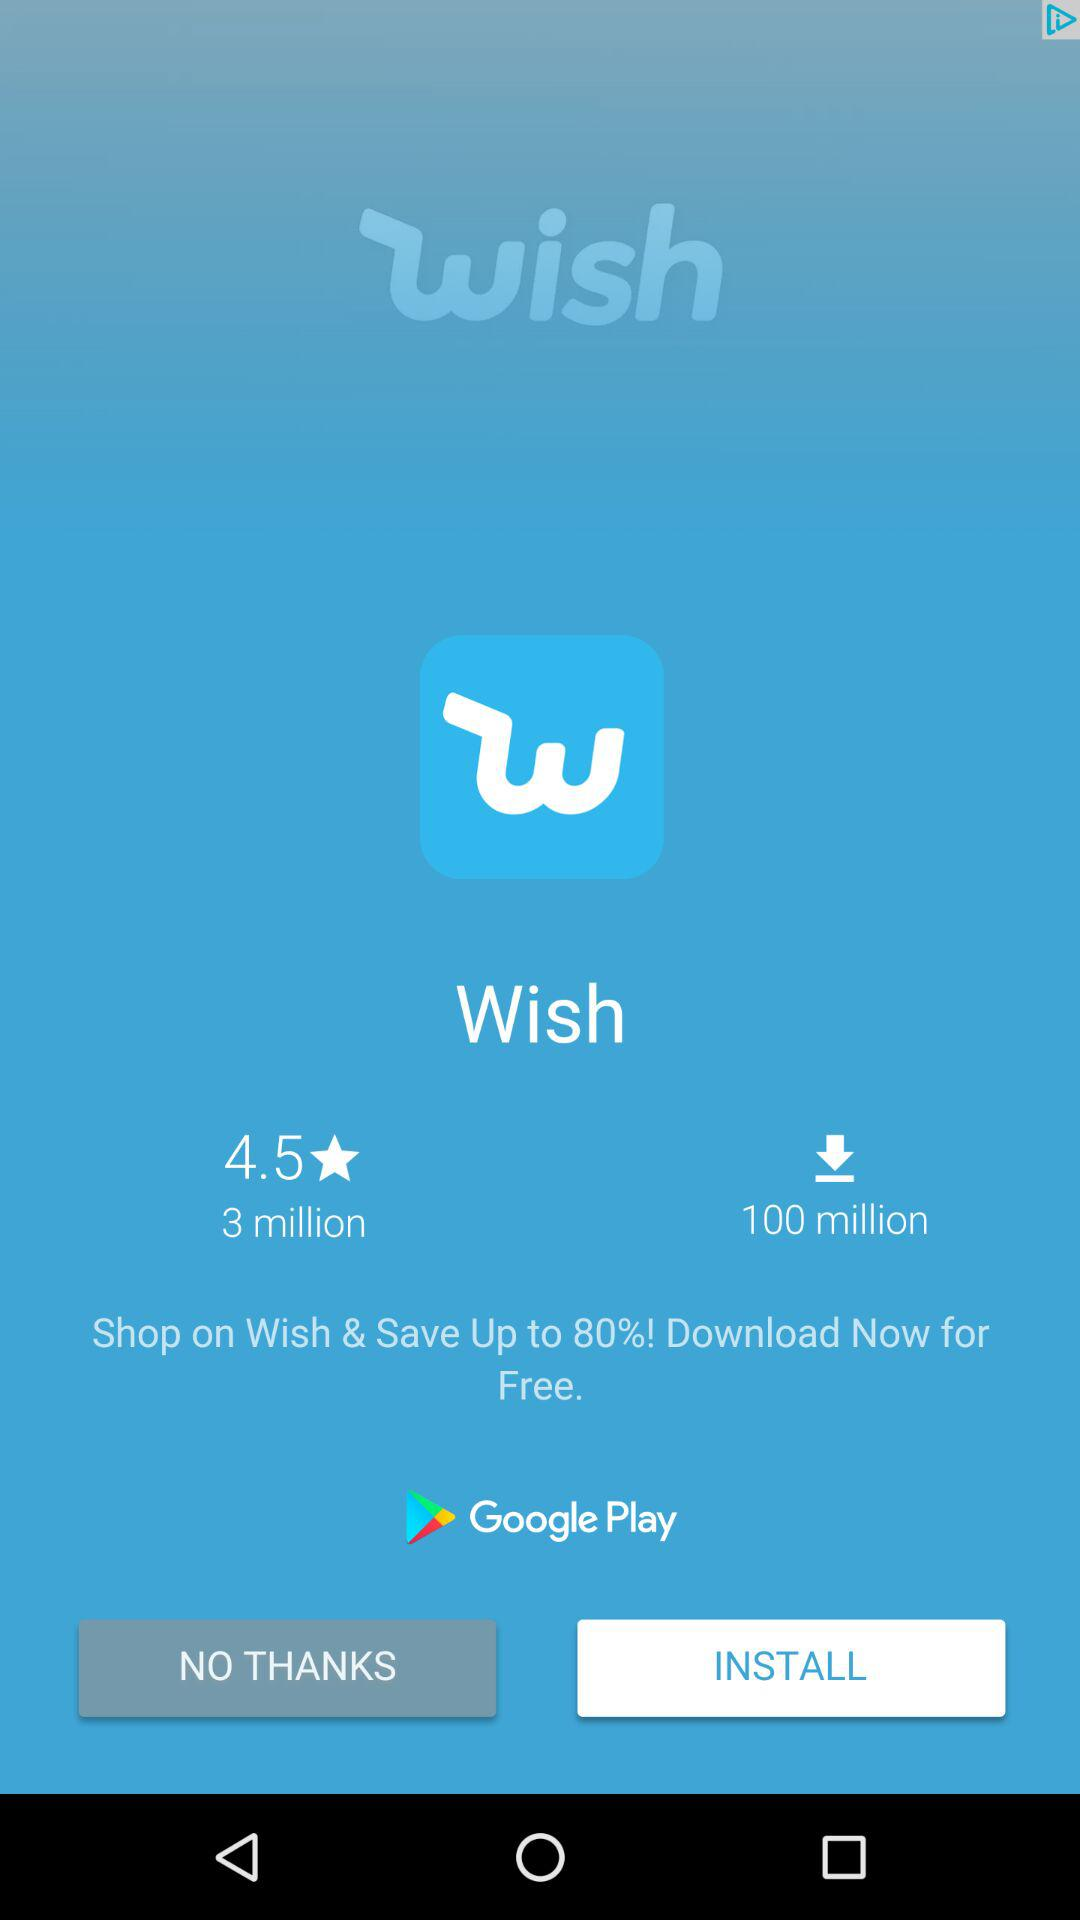How many more downloads does Wish have than reviews?
Answer the question using a single word or phrase. 97 million 